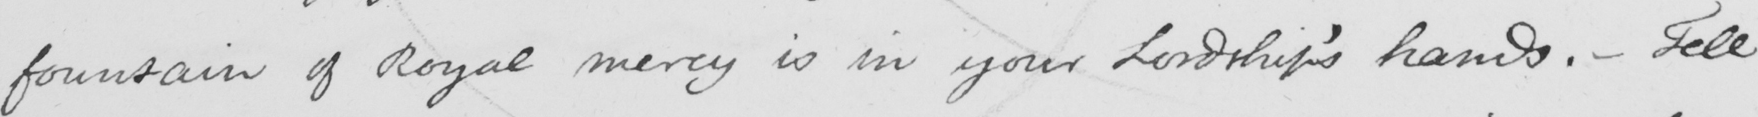Transcribe the text shown in this historical manuscript line. foundation of Royal mercy is in your Lordship ' s hands .  _  Tell 